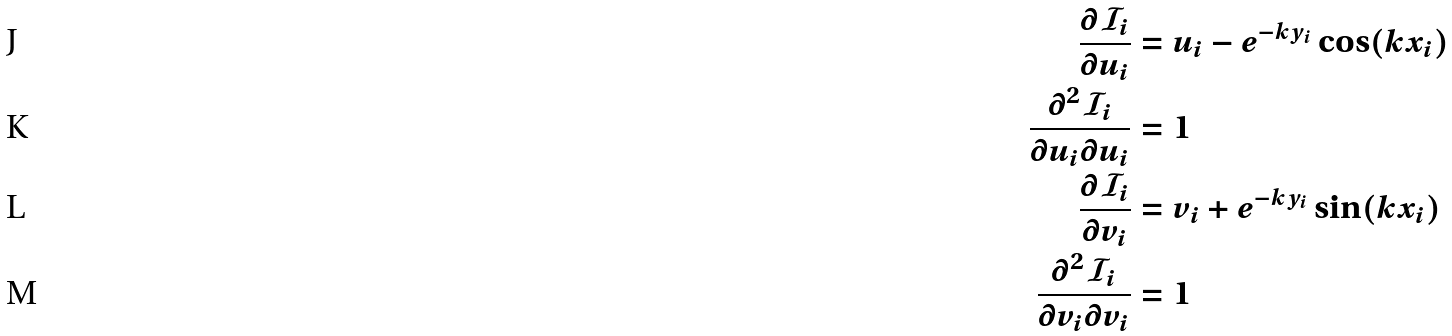Convert formula to latex. <formula><loc_0><loc_0><loc_500><loc_500>\frac { \partial \mathcal { I } _ { i } } { \partial u _ { i } } & = u _ { i } - e ^ { - k y _ { i } } \cos ( k x _ { i } ) \\ \frac { \partial ^ { 2 } \mathcal { I } _ { i } } { \partial u _ { i } \partial u _ { i } } & = 1 \\ \frac { \partial \mathcal { I } _ { i } } { \partial v _ { i } } & = v _ { i } + e ^ { - k y _ { i } } \sin ( k x _ { i } ) \\ \frac { \partial ^ { 2 } \mathcal { I } _ { i } } { \partial v _ { i } \partial v _ { i } } & = 1</formula> 